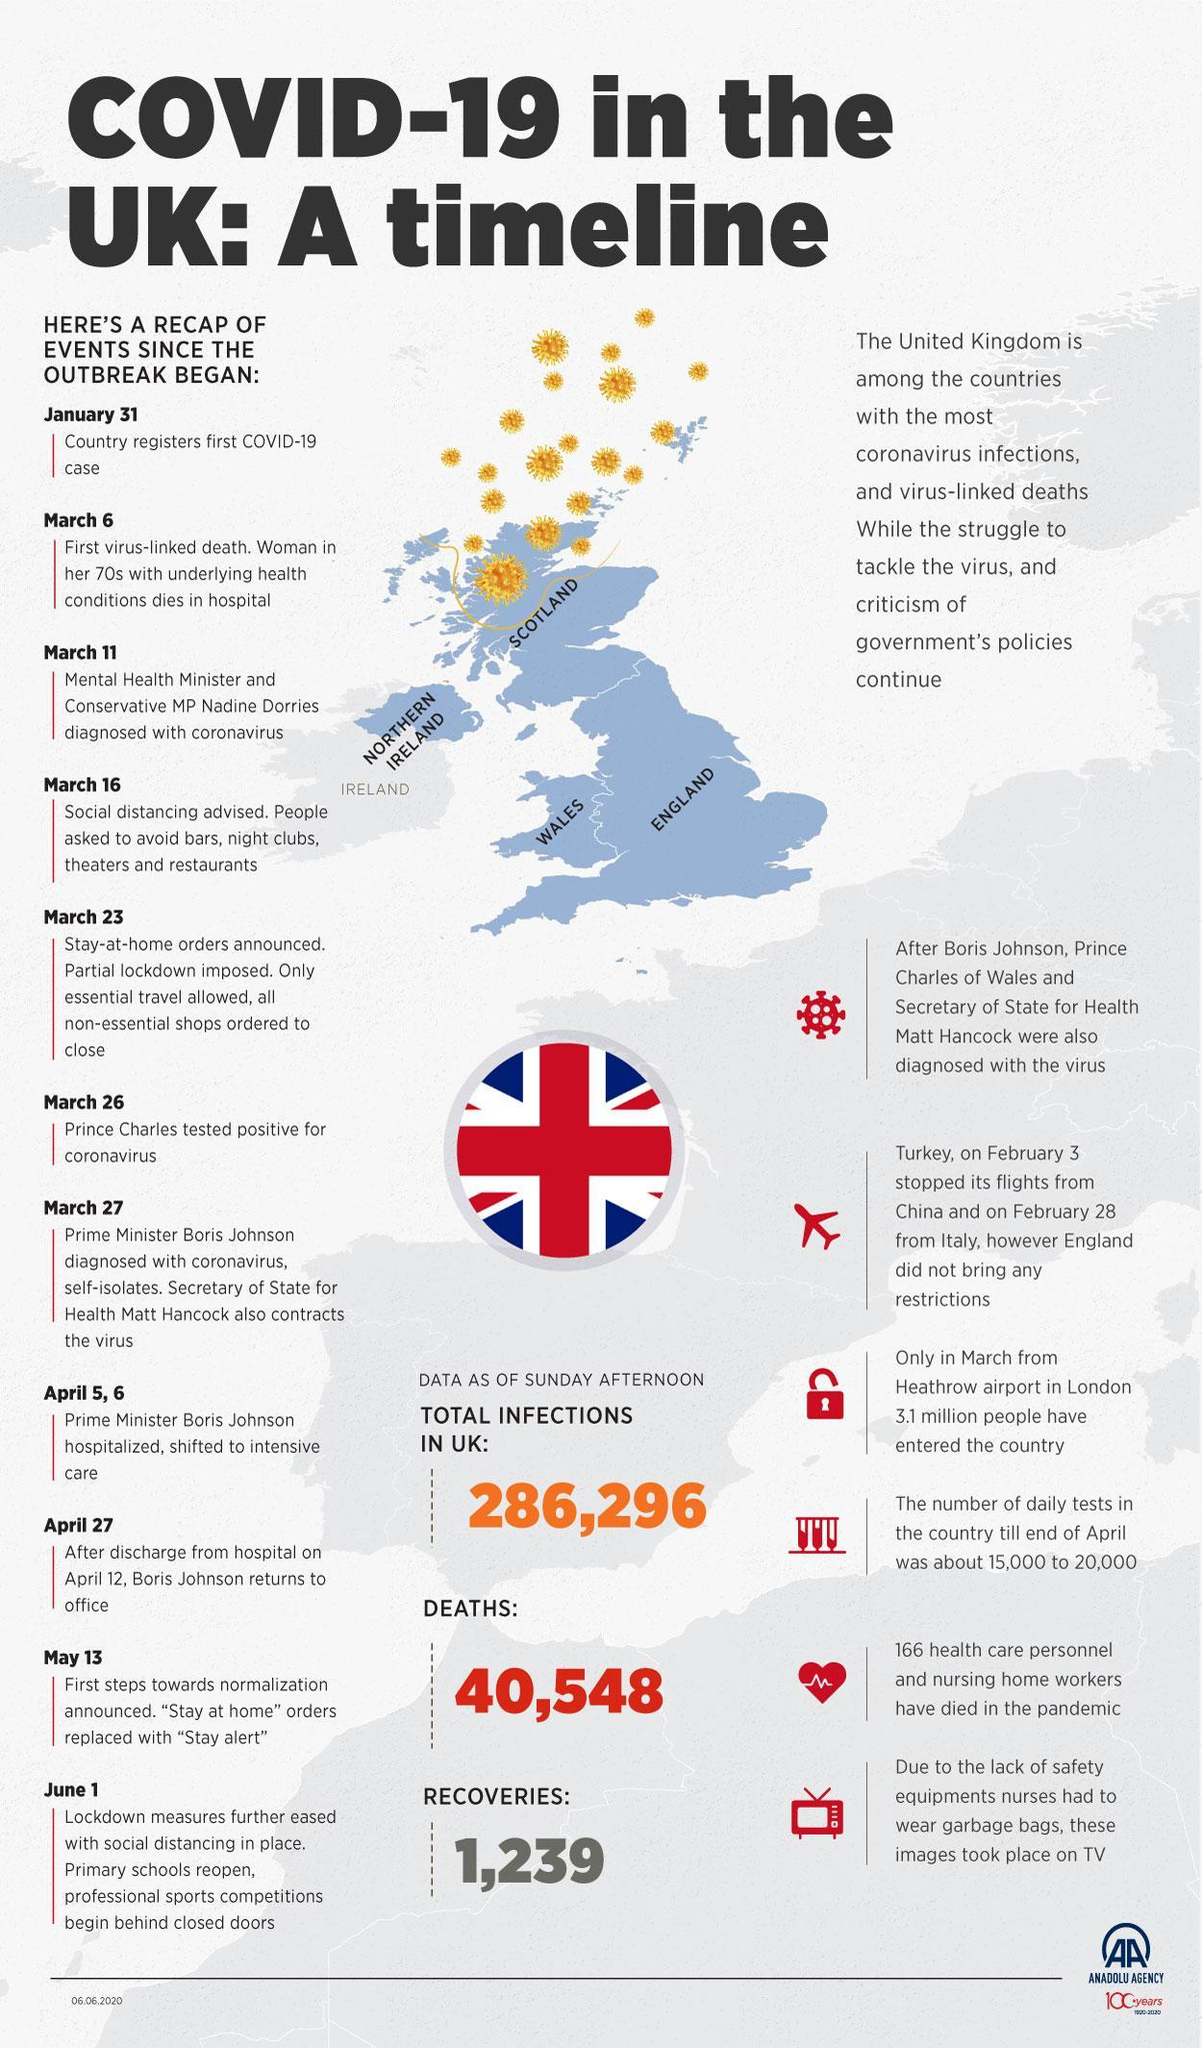How many total deaths reported in UK?
Answer the question with a short phrase. 40,548 Which country stopped flights from China and Italy? Turkey On which date did Boris Johnson return to office? April 27 When was partial lockdown imposed in England? March 23 Which member of the royal family contracted the virus? Prince Charles 